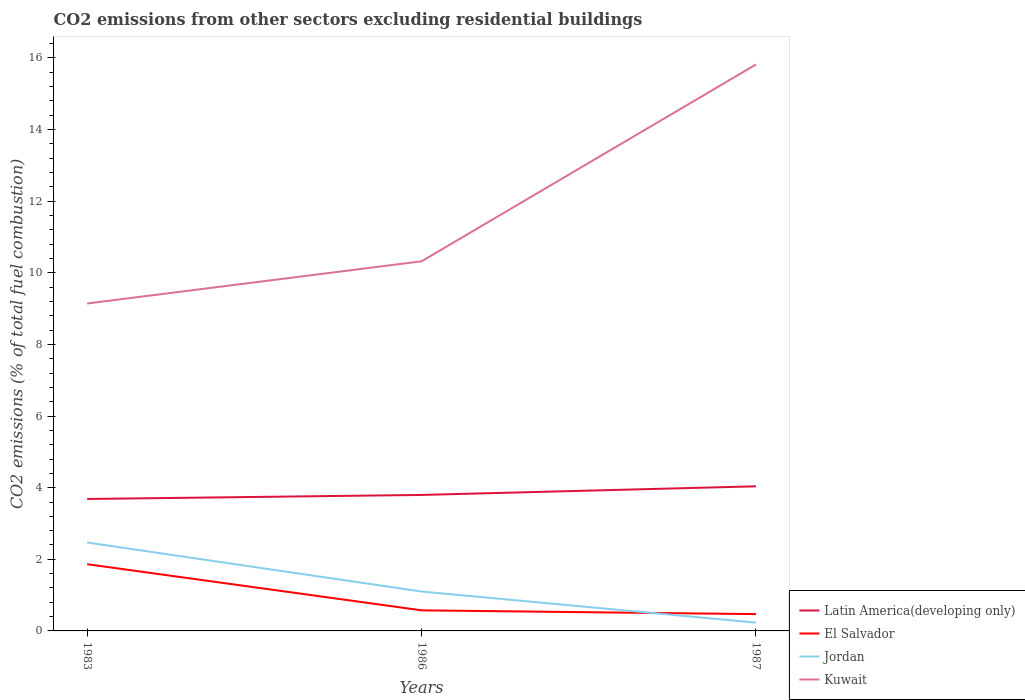Does the line corresponding to Kuwait intersect with the line corresponding to Jordan?
Offer a very short reply. No. Is the number of lines equal to the number of legend labels?
Provide a short and direct response. Yes. Across all years, what is the maximum total CO2 emitted in Kuwait?
Your response must be concise. 9.14. What is the total total CO2 emitted in El Salvador in the graph?
Offer a very short reply. 0.11. What is the difference between the highest and the second highest total CO2 emitted in Kuwait?
Give a very brief answer. 6.67. Is the total CO2 emitted in Latin America(developing only) strictly greater than the total CO2 emitted in Kuwait over the years?
Provide a short and direct response. Yes. How many lines are there?
Keep it short and to the point. 4. How many years are there in the graph?
Ensure brevity in your answer.  3. What is the difference between two consecutive major ticks on the Y-axis?
Keep it short and to the point. 2. Does the graph contain grids?
Make the answer very short. No. Where does the legend appear in the graph?
Your answer should be compact. Bottom right. How many legend labels are there?
Your answer should be very brief. 4. How are the legend labels stacked?
Keep it short and to the point. Vertical. What is the title of the graph?
Provide a succinct answer. CO2 emissions from other sectors excluding residential buildings. What is the label or title of the Y-axis?
Your answer should be compact. CO2 emissions (% of total fuel combustion). What is the CO2 emissions (% of total fuel combustion) of Latin America(developing only) in 1983?
Keep it short and to the point. 3.68. What is the CO2 emissions (% of total fuel combustion) of El Salvador in 1983?
Your response must be concise. 1.86. What is the CO2 emissions (% of total fuel combustion) in Jordan in 1983?
Give a very brief answer. 2.47. What is the CO2 emissions (% of total fuel combustion) in Kuwait in 1983?
Give a very brief answer. 9.14. What is the CO2 emissions (% of total fuel combustion) of Latin America(developing only) in 1986?
Your answer should be compact. 3.8. What is the CO2 emissions (% of total fuel combustion) in El Salvador in 1986?
Ensure brevity in your answer.  0.57. What is the CO2 emissions (% of total fuel combustion) in Jordan in 1986?
Offer a terse response. 1.1. What is the CO2 emissions (% of total fuel combustion) of Kuwait in 1986?
Ensure brevity in your answer.  10.32. What is the CO2 emissions (% of total fuel combustion) of Latin America(developing only) in 1987?
Provide a short and direct response. 4.04. What is the CO2 emissions (% of total fuel combustion) in El Salvador in 1987?
Make the answer very short. 0.47. What is the CO2 emissions (% of total fuel combustion) of Jordan in 1987?
Provide a short and direct response. 0.23. What is the CO2 emissions (% of total fuel combustion) in Kuwait in 1987?
Your response must be concise. 15.82. Across all years, what is the maximum CO2 emissions (% of total fuel combustion) in Latin America(developing only)?
Your answer should be compact. 4.04. Across all years, what is the maximum CO2 emissions (% of total fuel combustion) in El Salvador?
Provide a succinct answer. 1.86. Across all years, what is the maximum CO2 emissions (% of total fuel combustion) in Jordan?
Offer a very short reply. 2.47. Across all years, what is the maximum CO2 emissions (% of total fuel combustion) in Kuwait?
Make the answer very short. 15.82. Across all years, what is the minimum CO2 emissions (% of total fuel combustion) in Latin America(developing only)?
Offer a very short reply. 3.68. Across all years, what is the minimum CO2 emissions (% of total fuel combustion) in El Salvador?
Make the answer very short. 0.47. Across all years, what is the minimum CO2 emissions (% of total fuel combustion) of Jordan?
Give a very brief answer. 0.23. Across all years, what is the minimum CO2 emissions (% of total fuel combustion) of Kuwait?
Your response must be concise. 9.14. What is the total CO2 emissions (% of total fuel combustion) in Latin America(developing only) in the graph?
Provide a short and direct response. 11.52. What is the total CO2 emissions (% of total fuel combustion) of El Salvador in the graph?
Your answer should be compact. 2.91. What is the total CO2 emissions (% of total fuel combustion) of Jordan in the graph?
Your answer should be very brief. 3.8. What is the total CO2 emissions (% of total fuel combustion) in Kuwait in the graph?
Offer a very short reply. 35.28. What is the difference between the CO2 emissions (% of total fuel combustion) in Latin America(developing only) in 1983 and that in 1986?
Provide a short and direct response. -0.11. What is the difference between the CO2 emissions (% of total fuel combustion) of El Salvador in 1983 and that in 1986?
Offer a terse response. 1.29. What is the difference between the CO2 emissions (% of total fuel combustion) in Jordan in 1983 and that in 1986?
Offer a terse response. 1.37. What is the difference between the CO2 emissions (% of total fuel combustion) in Kuwait in 1983 and that in 1986?
Keep it short and to the point. -1.18. What is the difference between the CO2 emissions (% of total fuel combustion) of Latin America(developing only) in 1983 and that in 1987?
Provide a succinct answer. -0.35. What is the difference between the CO2 emissions (% of total fuel combustion) of El Salvador in 1983 and that in 1987?
Make the answer very short. 1.39. What is the difference between the CO2 emissions (% of total fuel combustion) of Jordan in 1983 and that in 1987?
Provide a short and direct response. 2.24. What is the difference between the CO2 emissions (% of total fuel combustion) in Kuwait in 1983 and that in 1987?
Make the answer very short. -6.67. What is the difference between the CO2 emissions (% of total fuel combustion) in Latin America(developing only) in 1986 and that in 1987?
Offer a very short reply. -0.24. What is the difference between the CO2 emissions (% of total fuel combustion) in El Salvador in 1986 and that in 1987?
Your answer should be compact. 0.11. What is the difference between the CO2 emissions (% of total fuel combustion) in Jordan in 1986 and that in 1987?
Provide a short and direct response. 0.87. What is the difference between the CO2 emissions (% of total fuel combustion) of Kuwait in 1986 and that in 1987?
Your response must be concise. -5.5. What is the difference between the CO2 emissions (% of total fuel combustion) in Latin America(developing only) in 1983 and the CO2 emissions (% of total fuel combustion) in El Salvador in 1986?
Your response must be concise. 3.11. What is the difference between the CO2 emissions (% of total fuel combustion) of Latin America(developing only) in 1983 and the CO2 emissions (% of total fuel combustion) of Jordan in 1986?
Ensure brevity in your answer.  2.58. What is the difference between the CO2 emissions (% of total fuel combustion) in Latin America(developing only) in 1983 and the CO2 emissions (% of total fuel combustion) in Kuwait in 1986?
Provide a succinct answer. -6.64. What is the difference between the CO2 emissions (% of total fuel combustion) in El Salvador in 1983 and the CO2 emissions (% of total fuel combustion) in Jordan in 1986?
Your answer should be compact. 0.76. What is the difference between the CO2 emissions (% of total fuel combustion) of El Salvador in 1983 and the CO2 emissions (% of total fuel combustion) of Kuwait in 1986?
Your answer should be compact. -8.46. What is the difference between the CO2 emissions (% of total fuel combustion) in Jordan in 1983 and the CO2 emissions (% of total fuel combustion) in Kuwait in 1986?
Offer a terse response. -7.85. What is the difference between the CO2 emissions (% of total fuel combustion) of Latin America(developing only) in 1983 and the CO2 emissions (% of total fuel combustion) of El Salvador in 1987?
Provide a succinct answer. 3.21. What is the difference between the CO2 emissions (% of total fuel combustion) of Latin America(developing only) in 1983 and the CO2 emissions (% of total fuel combustion) of Jordan in 1987?
Provide a short and direct response. 3.45. What is the difference between the CO2 emissions (% of total fuel combustion) in Latin America(developing only) in 1983 and the CO2 emissions (% of total fuel combustion) in Kuwait in 1987?
Keep it short and to the point. -12.13. What is the difference between the CO2 emissions (% of total fuel combustion) of El Salvador in 1983 and the CO2 emissions (% of total fuel combustion) of Jordan in 1987?
Make the answer very short. 1.63. What is the difference between the CO2 emissions (% of total fuel combustion) of El Salvador in 1983 and the CO2 emissions (% of total fuel combustion) of Kuwait in 1987?
Offer a very short reply. -13.95. What is the difference between the CO2 emissions (% of total fuel combustion) in Jordan in 1983 and the CO2 emissions (% of total fuel combustion) in Kuwait in 1987?
Give a very brief answer. -13.35. What is the difference between the CO2 emissions (% of total fuel combustion) of Latin America(developing only) in 1986 and the CO2 emissions (% of total fuel combustion) of El Salvador in 1987?
Make the answer very short. 3.33. What is the difference between the CO2 emissions (% of total fuel combustion) of Latin America(developing only) in 1986 and the CO2 emissions (% of total fuel combustion) of Jordan in 1987?
Your answer should be very brief. 3.57. What is the difference between the CO2 emissions (% of total fuel combustion) of Latin America(developing only) in 1986 and the CO2 emissions (% of total fuel combustion) of Kuwait in 1987?
Provide a short and direct response. -12.02. What is the difference between the CO2 emissions (% of total fuel combustion) in El Salvador in 1986 and the CO2 emissions (% of total fuel combustion) in Jordan in 1987?
Make the answer very short. 0.34. What is the difference between the CO2 emissions (% of total fuel combustion) of El Salvador in 1986 and the CO2 emissions (% of total fuel combustion) of Kuwait in 1987?
Ensure brevity in your answer.  -15.24. What is the difference between the CO2 emissions (% of total fuel combustion) of Jordan in 1986 and the CO2 emissions (% of total fuel combustion) of Kuwait in 1987?
Keep it short and to the point. -14.72. What is the average CO2 emissions (% of total fuel combustion) in Latin America(developing only) per year?
Your answer should be very brief. 3.84. What is the average CO2 emissions (% of total fuel combustion) in El Salvador per year?
Ensure brevity in your answer.  0.97. What is the average CO2 emissions (% of total fuel combustion) in Jordan per year?
Your response must be concise. 1.27. What is the average CO2 emissions (% of total fuel combustion) in Kuwait per year?
Give a very brief answer. 11.76. In the year 1983, what is the difference between the CO2 emissions (% of total fuel combustion) in Latin America(developing only) and CO2 emissions (% of total fuel combustion) in El Salvador?
Give a very brief answer. 1.82. In the year 1983, what is the difference between the CO2 emissions (% of total fuel combustion) in Latin America(developing only) and CO2 emissions (% of total fuel combustion) in Jordan?
Your response must be concise. 1.22. In the year 1983, what is the difference between the CO2 emissions (% of total fuel combustion) of Latin America(developing only) and CO2 emissions (% of total fuel combustion) of Kuwait?
Give a very brief answer. -5.46. In the year 1983, what is the difference between the CO2 emissions (% of total fuel combustion) of El Salvador and CO2 emissions (% of total fuel combustion) of Jordan?
Give a very brief answer. -0.61. In the year 1983, what is the difference between the CO2 emissions (% of total fuel combustion) in El Salvador and CO2 emissions (% of total fuel combustion) in Kuwait?
Your response must be concise. -7.28. In the year 1983, what is the difference between the CO2 emissions (% of total fuel combustion) of Jordan and CO2 emissions (% of total fuel combustion) of Kuwait?
Make the answer very short. -6.67. In the year 1986, what is the difference between the CO2 emissions (% of total fuel combustion) in Latin America(developing only) and CO2 emissions (% of total fuel combustion) in El Salvador?
Offer a terse response. 3.22. In the year 1986, what is the difference between the CO2 emissions (% of total fuel combustion) in Latin America(developing only) and CO2 emissions (% of total fuel combustion) in Jordan?
Provide a short and direct response. 2.7. In the year 1986, what is the difference between the CO2 emissions (% of total fuel combustion) in Latin America(developing only) and CO2 emissions (% of total fuel combustion) in Kuwait?
Provide a short and direct response. -6.52. In the year 1986, what is the difference between the CO2 emissions (% of total fuel combustion) of El Salvador and CO2 emissions (% of total fuel combustion) of Jordan?
Provide a succinct answer. -0.53. In the year 1986, what is the difference between the CO2 emissions (% of total fuel combustion) of El Salvador and CO2 emissions (% of total fuel combustion) of Kuwait?
Your answer should be compact. -9.75. In the year 1986, what is the difference between the CO2 emissions (% of total fuel combustion) of Jordan and CO2 emissions (% of total fuel combustion) of Kuwait?
Your answer should be compact. -9.22. In the year 1987, what is the difference between the CO2 emissions (% of total fuel combustion) of Latin America(developing only) and CO2 emissions (% of total fuel combustion) of El Salvador?
Make the answer very short. 3.57. In the year 1987, what is the difference between the CO2 emissions (% of total fuel combustion) in Latin America(developing only) and CO2 emissions (% of total fuel combustion) in Jordan?
Offer a terse response. 3.81. In the year 1987, what is the difference between the CO2 emissions (% of total fuel combustion) in Latin America(developing only) and CO2 emissions (% of total fuel combustion) in Kuwait?
Your answer should be very brief. -11.78. In the year 1987, what is the difference between the CO2 emissions (% of total fuel combustion) in El Salvador and CO2 emissions (% of total fuel combustion) in Jordan?
Make the answer very short. 0.24. In the year 1987, what is the difference between the CO2 emissions (% of total fuel combustion) of El Salvador and CO2 emissions (% of total fuel combustion) of Kuwait?
Offer a very short reply. -15.35. In the year 1987, what is the difference between the CO2 emissions (% of total fuel combustion) of Jordan and CO2 emissions (% of total fuel combustion) of Kuwait?
Keep it short and to the point. -15.59. What is the ratio of the CO2 emissions (% of total fuel combustion) in Latin America(developing only) in 1983 to that in 1986?
Make the answer very short. 0.97. What is the ratio of the CO2 emissions (% of total fuel combustion) in El Salvador in 1983 to that in 1986?
Offer a terse response. 3.24. What is the ratio of the CO2 emissions (% of total fuel combustion) of Jordan in 1983 to that in 1986?
Provide a short and direct response. 2.24. What is the ratio of the CO2 emissions (% of total fuel combustion) in Kuwait in 1983 to that in 1986?
Make the answer very short. 0.89. What is the ratio of the CO2 emissions (% of total fuel combustion) in Latin America(developing only) in 1983 to that in 1987?
Make the answer very short. 0.91. What is the ratio of the CO2 emissions (% of total fuel combustion) in El Salvador in 1983 to that in 1987?
Your answer should be compact. 3.97. What is the ratio of the CO2 emissions (% of total fuel combustion) in Jordan in 1983 to that in 1987?
Ensure brevity in your answer.  10.65. What is the ratio of the CO2 emissions (% of total fuel combustion) in Kuwait in 1983 to that in 1987?
Give a very brief answer. 0.58. What is the ratio of the CO2 emissions (% of total fuel combustion) in Latin America(developing only) in 1986 to that in 1987?
Your answer should be very brief. 0.94. What is the ratio of the CO2 emissions (% of total fuel combustion) of El Salvador in 1986 to that in 1987?
Your answer should be very brief. 1.22. What is the ratio of the CO2 emissions (% of total fuel combustion) in Jordan in 1986 to that in 1987?
Provide a succinct answer. 4.75. What is the ratio of the CO2 emissions (% of total fuel combustion) of Kuwait in 1986 to that in 1987?
Ensure brevity in your answer.  0.65. What is the difference between the highest and the second highest CO2 emissions (% of total fuel combustion) in Latin America(developing only)?
Offer a terse response. 0.24. What is the difference between the highest and the second highest CO2 emissions (% of total fuel combustion) in El Salvador?
Keep it short and to the point. 1.29. What is the difference between the highest and the second highest CO2 emissions (% of total fuel combustion) of Jordan?
Keep it short and to the point. 1.37. What is the difference between the highest and the second highest CO2 emissions (% of total fuel combustion) in Kuwait?
Offer a terse response. 5.5. What is the difference between the highest and the lowest CO2 emissions (% of total fuel combustion) of Latin America(developing only)?
Ensure brevity in your answer.  0.35. What is the difference between the highest and the lowest CO2 emissions (% of total fuel combustion) of El Salvador?
Your answer should be very brief. 1.39. What is the difference between the highest and the lowest CO2 emissions (% of total fuel combustion) of Jordan?
Ensure brevity in your answer.  2.24. What is the difference between the highest and the lowest CO2 emissions (% of total fuel combustion) in Kuwait?
Your answer should be compact. 6.67. 